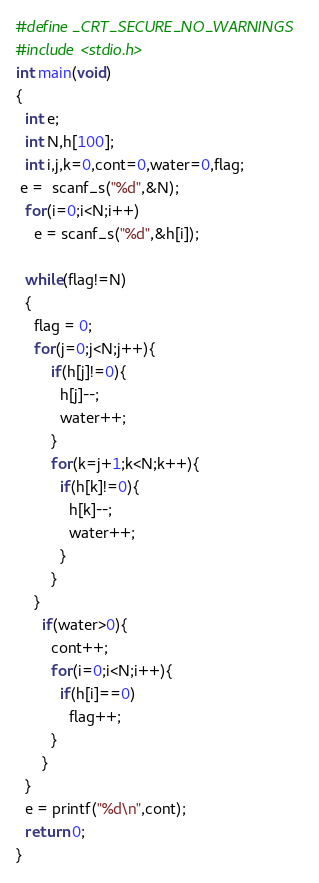Convert code to text. <code><loc_0><loc_0><loc_500><loc_500><_C_>#define _CRT_SECURE_NO_WARNINGS
#include <stdio.h>
int main(void)
{
  int e;
  int N,h[100];
  int i,j,k=0,cont=0,water=0,flag;
 e =  scanf_s("%d",&N);
  for(i=0;i<N;i++)
    e = scanf_s("%d",&h[i]);
  
  while(flag!=N)
  {
    flag = 0;
  	for(j=0;j<N;j++){
    	if(h[j]!=0){
          h[j]--;
          water++;
        }
        for(k=j+1;k<N;k++){
          if(h[k]!=0){
            h[k]--;
            water++;
          }
        }
    }
      if(water>0){
        cont++;
        for(i=0;i<N;i++){
          if(h[i]==0)
            flag++;
        }
      }
  }
  e = printf("%d\n",cont);
  return 0;
}</code> 